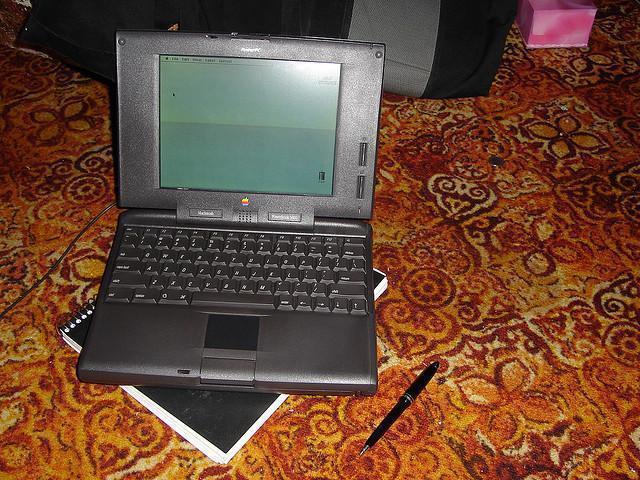What company made the black laptop on the black notebook?
Choose the correct response and explain in the format: 'Answer: answer
Rationale: rationale.'
Options: Hp, dell, apple, sony. Answer: apple.
Rationale: The logo on the laptop is that of the apple company. 